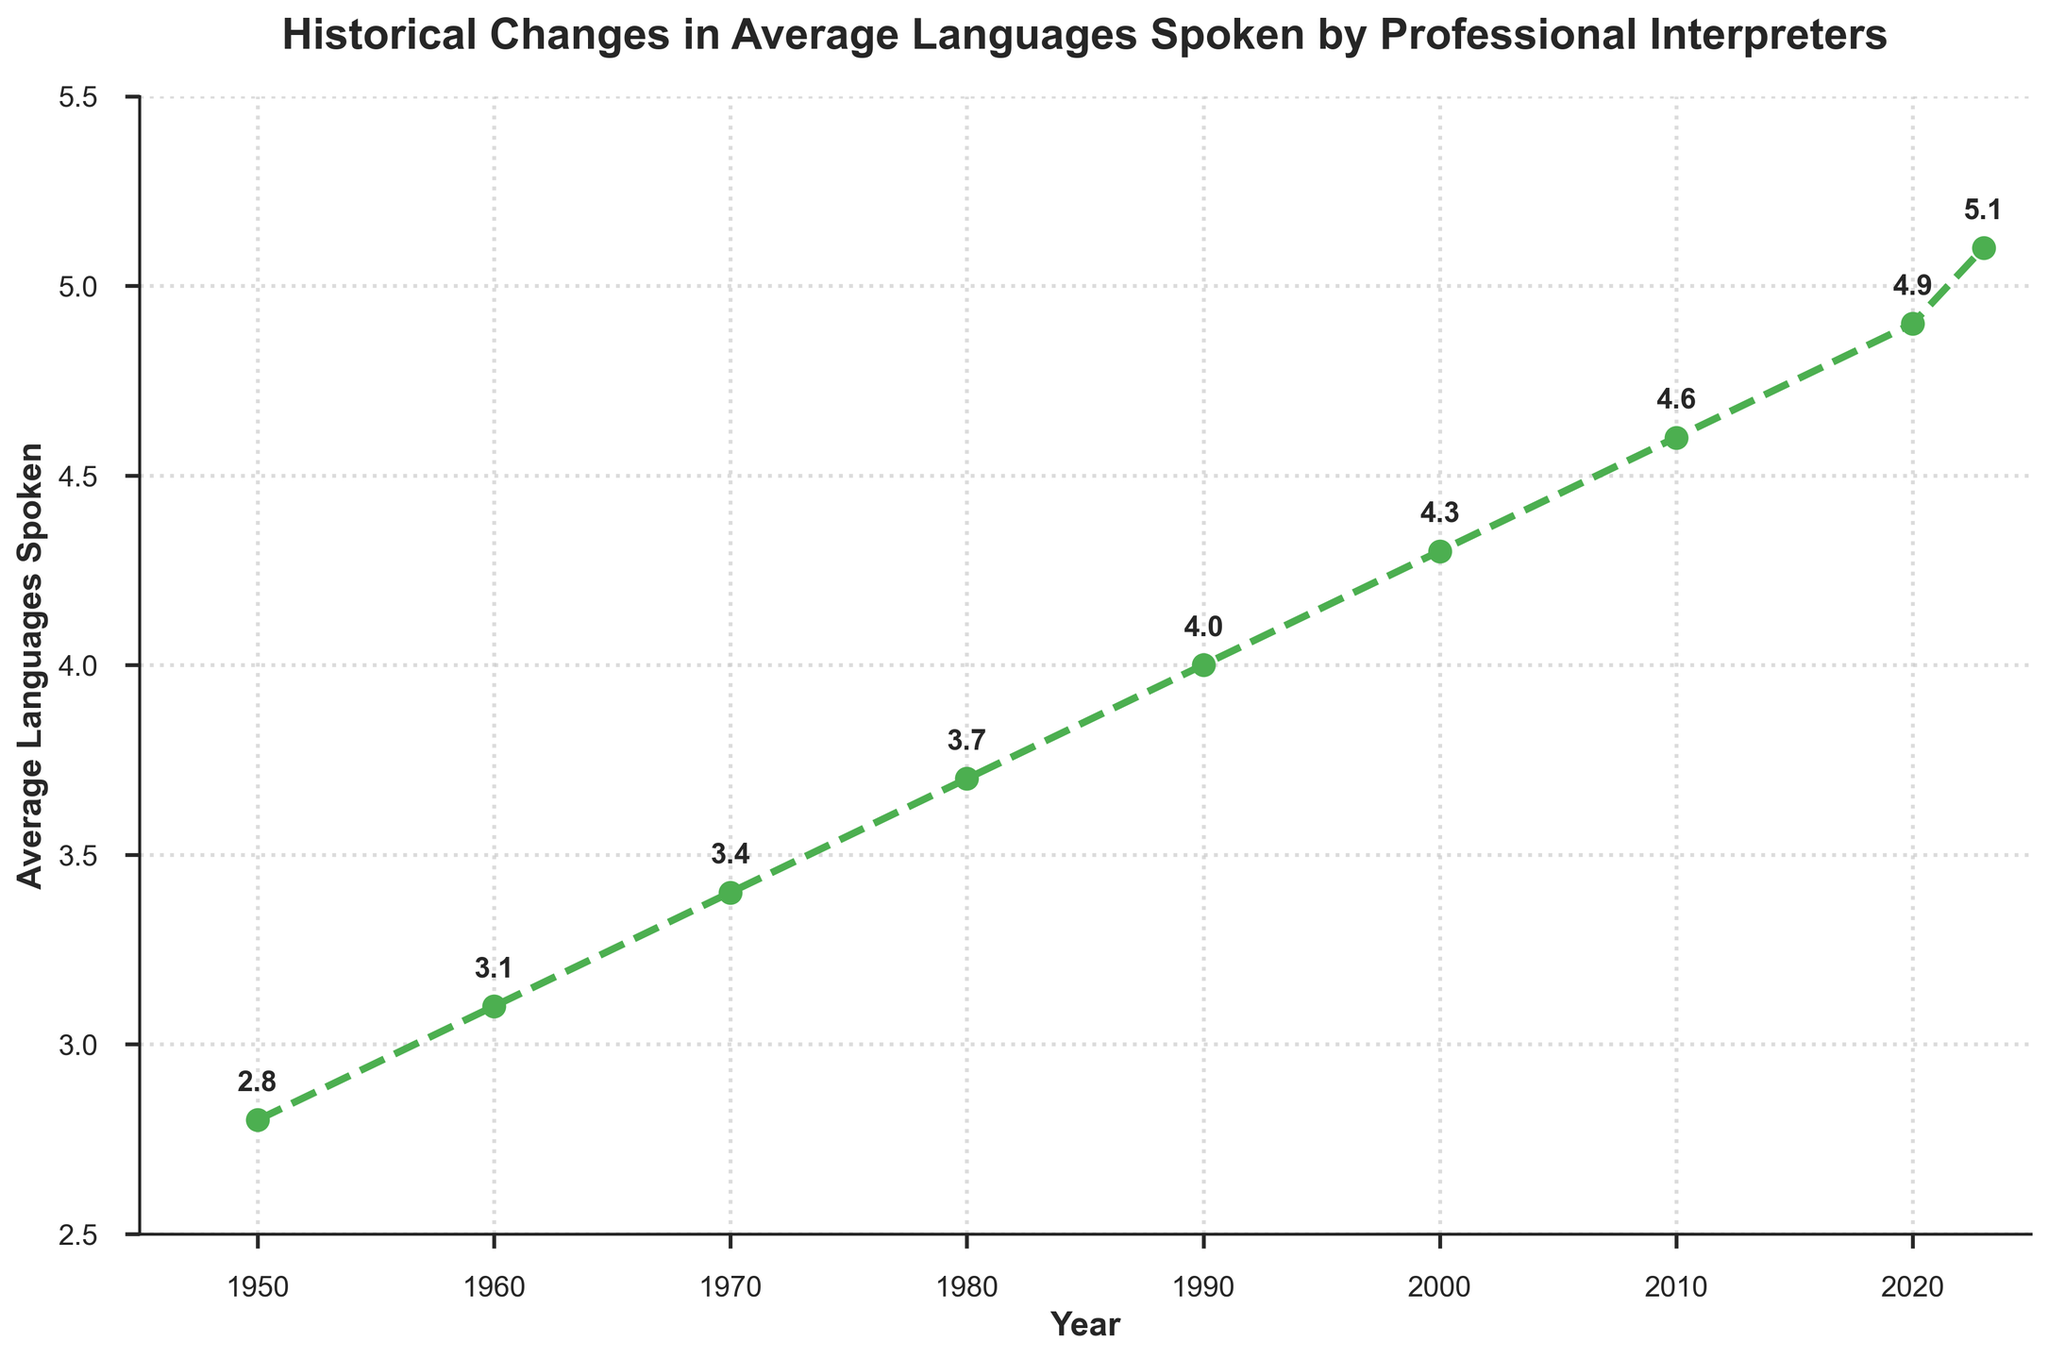What is the average number of languages spoken by professional interpreters in 1970? The graph shows data points for each year, and in 1970 it indicates that professional interpreters spoke an average of 3.4 languages.
Answer: 3.4 Has the average number of languages spoken increased or decreased from 2000 to 2020? According to the graph, the average number of languages spoken was 4.3 in 2000 and 4.9 in 2020. Since 4.9 is greater than 4.3, it has increased during this period.
Answer: Increased What is the difference in the average number of languages spoken between 1950 and 2023? In 1950, the average number of languages spoken was 2.8, and in 2023, it was 5.1. The difference between these two values is calculated as 5.1 - 2.8 = 2.3.
Answer: 2.3 What trend does the graph show from 1950 to the present regarding the average number of languages spoken by professional interpreters? The graph illustrates a consistent upward trend from 1950 to the present, indicating that the average number of languages spoken by professional interpreters has been increasing over time.
Answer: Increasing Which year saw the highest average number of languages spoken by professional interpreters, and what was the value? By looking at the data points, it is visible that 2023 has the highest value on the graph, showing an average of 5.1 languages spoken.
Answer: 2023, 5.1 Compare the average number of languages spoken in 1980 and 2010. Which year had a higher value? The graph shows that in 1980 the value was 3.7, and in 2010 it was 4.6. By comparing these numbers, it is clear that 2010 had a higher average number of languages spoken than 1980.
Answer: 2010 Between which consecutive decades was the largest increase in the average number of languages spoken observed? The increases between consecutive decades are as follows:
1960-1970: 3.1 to 3.4 (0.3 increase)
1970-1980: 3.4 to 3.7 (0.3 increase)
1980-1990: 3.7 to 4.0 (0.3 increase)
1990-2000: 4.0 to 4.3 (0.3 increase)
2000-2010: 4.3 to 4.6 (0.3 increase)
2010-2020: 4.6 to 4.9 (0.3 increase)
There are no increases larger than 0.3, so the largest increase is observed between any pair of consecutive decades listed.
Answer: 0.3 increase between all consecutive decades What is the overall percentage increase in the average number of languages spoken from 1950 to 2023? From 1950 to 2023, the average number of languages spoken increased from 2.8 to 5.1. The percentage increase is calculated by [(5.1 - 2.8) / 2.8] * 100 = 82.14%.
Answer: 82.14% Describe the color and style used for the line in the graph. The line in the graph is green and uses a dashed pattern with circular markers.
Answer: Green, dashed with circular markers 